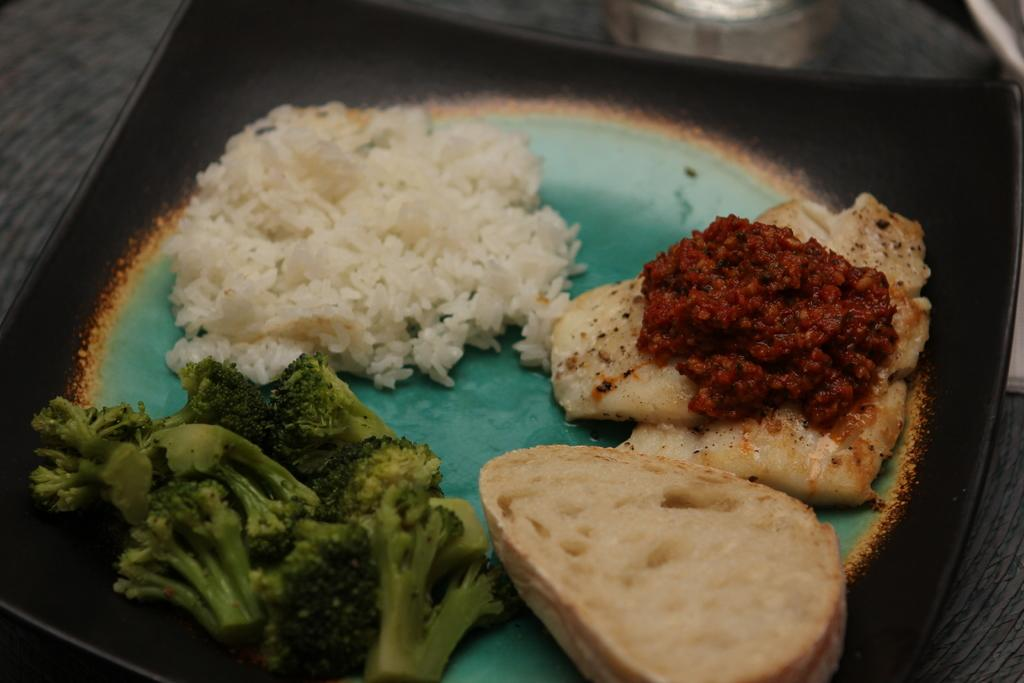What is on the plate that is visible in the image? There is food on a plate in the image. Where is the plate located in the image? The plate is placed on a table. What type of lipstick is being tested on the food in the image? There is no lipstick or testing present in the image; it only features food on a plate placed on a table. 